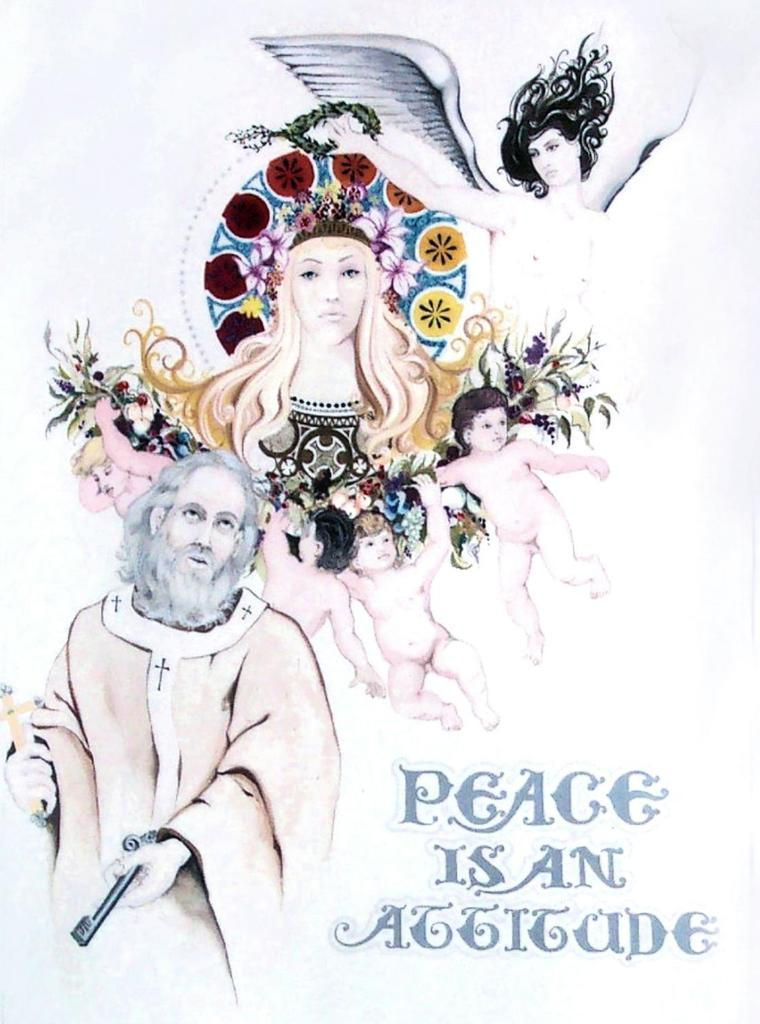What is featured in the picture? There is a poster in the picture. What type of images are on the poster? The poster contains animated pictures. Are there any words on the poster? Yes, there is text on the poster. What type of zinc can be seen growing on the flower in the image? There is no flower or zinc present in the image; the poster contains animated pictures and text. 